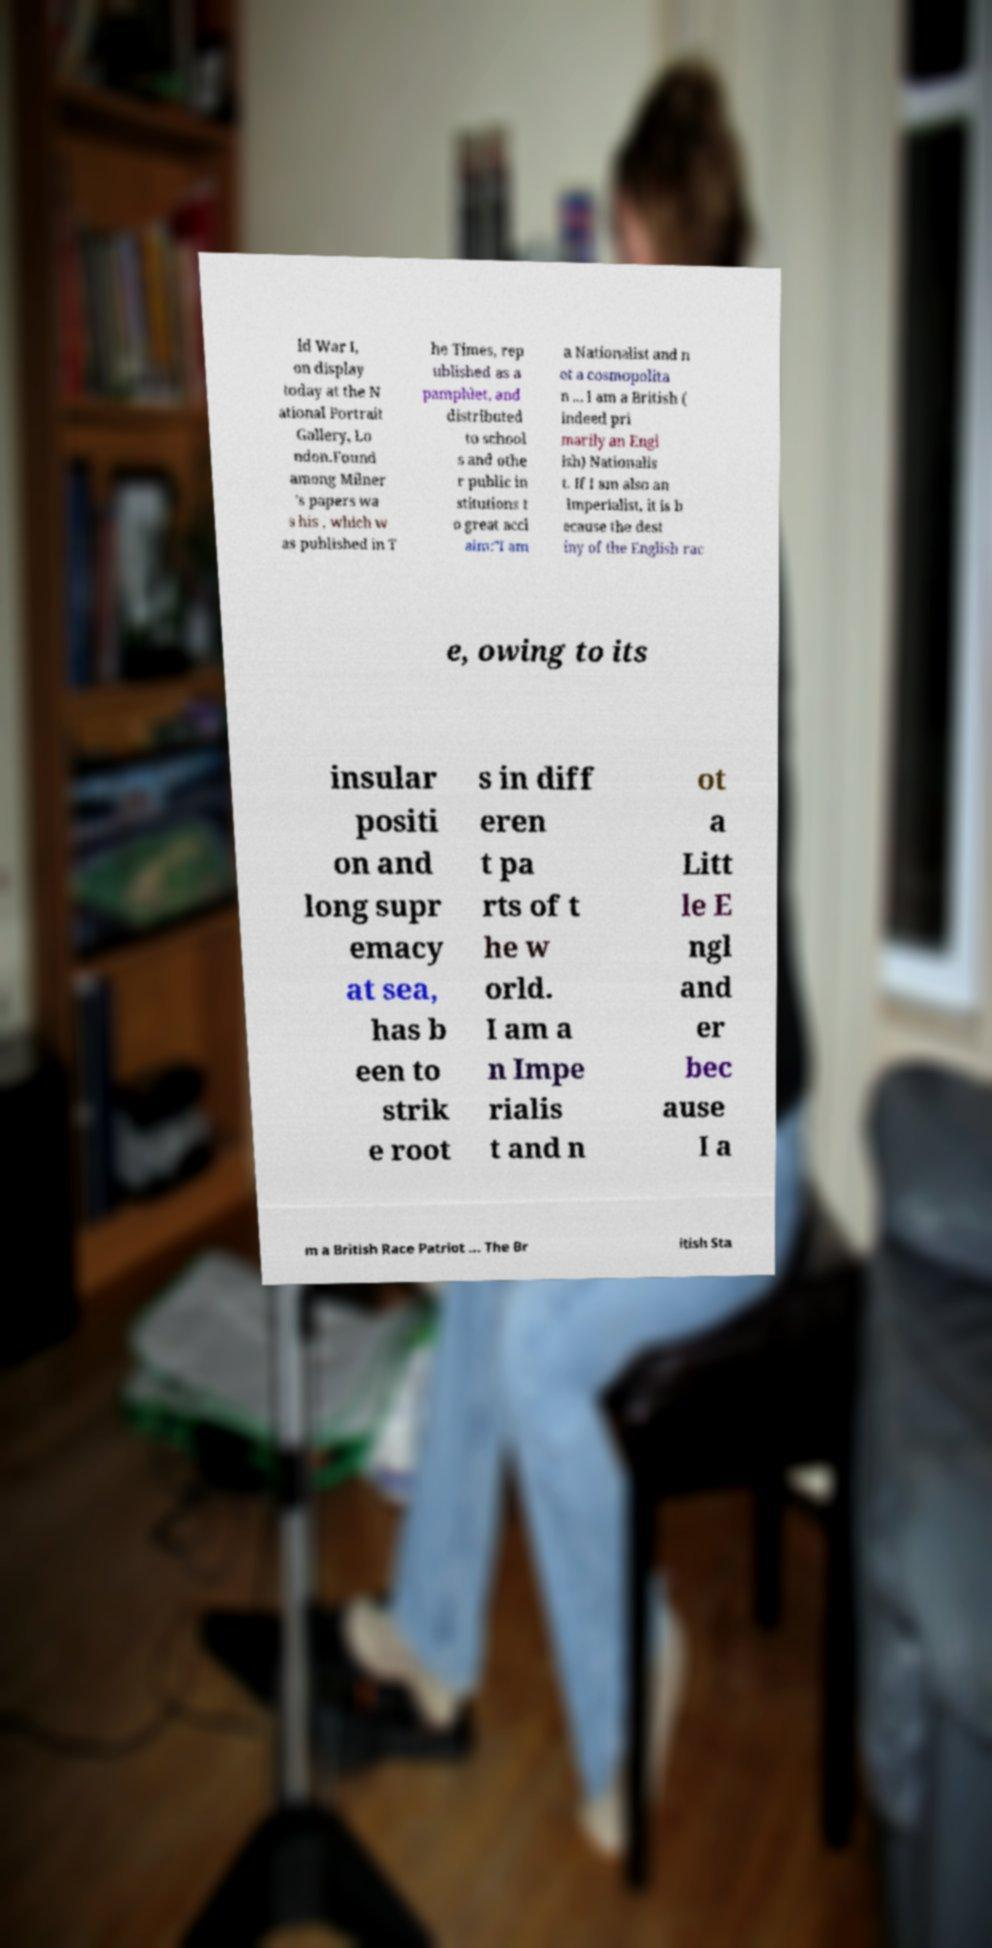Can you read and provide the text displayed in the image?This photo seems to have some interesting text. Can you extract and type it out for me? ld War I, on display today at the N ational Portrait Gallery, Lo ndon.Found among Milner 's papers wa s his , which w as published in T he Times, rep ublished as a pamphlet, and distributed to school s and othe r public in stitutions t o great accl aim:"I am a Nationalist and n ot a cosmopolita n ... I am a British ( indeed pri marily an Engl ish) Nationalis t. If I am also an Imperialist, it is b ecause the dest iny of the English rac e, owing to its insular positi on and long supr emacy at sea, has b een to strik e root s in diff eren t pa rts of t he w orld. I am a n Impe rialis t and n ot a Litt le E ngl and er bec ause I a m a British Race Patriot ... The Br itish Sta 